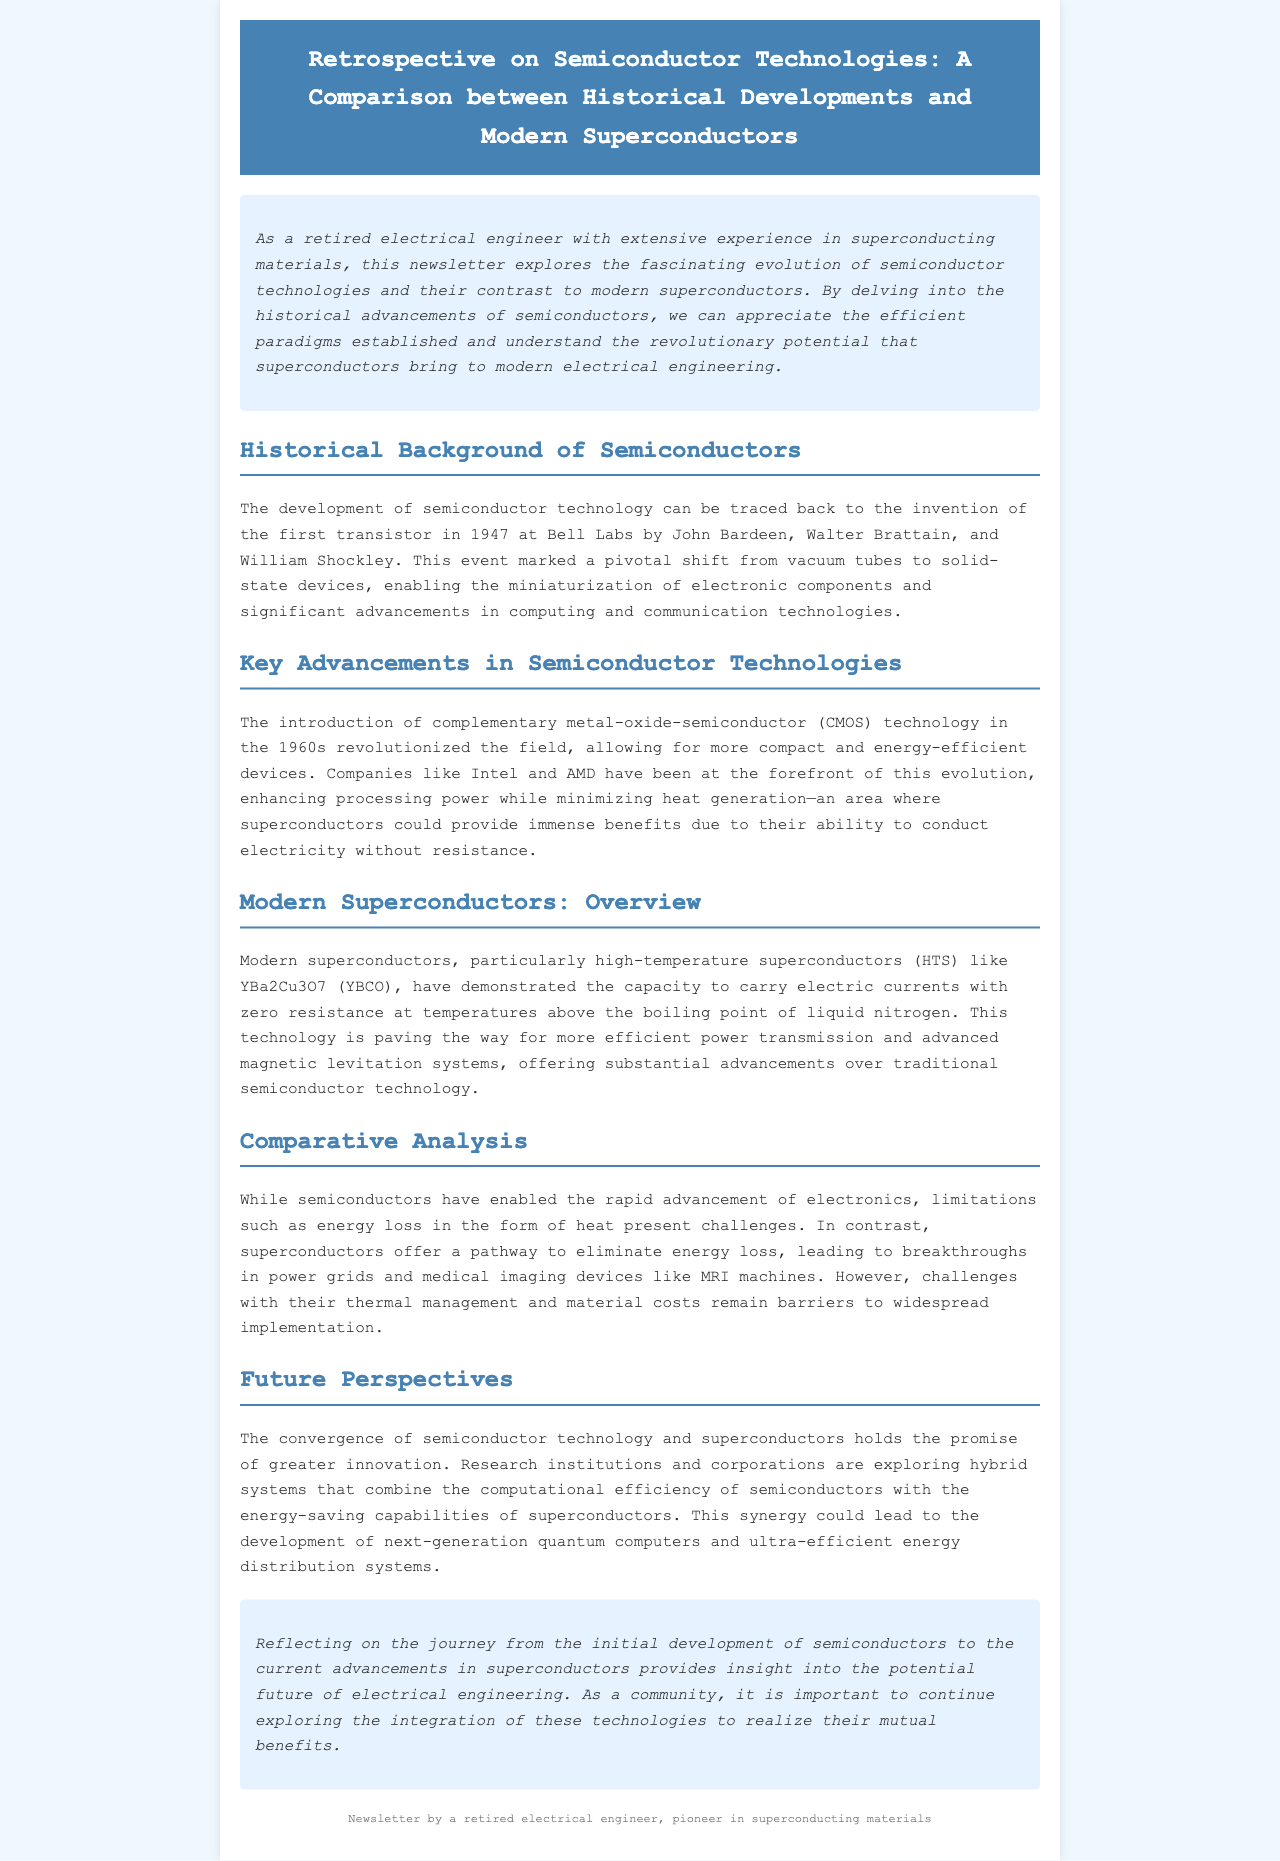What year was the first transistor invented? The document states that the first transistor was invented in 1947 at Bell Labs.
Answer: 1947 Which technology revolutionized the field of semiconductors in the 1960s? The introduction of complementary metal-oxide-semiconductor (CMOS) technology in the 1960s is mentioned as a revolutionary advancement.
Answer: CMOS technology What is an example of a modern superconductor provided in the newsletter? The document mentions YBa2Cu3O7 (YBCO) as an example of a high-temperature superconductor.
Answer: YBa2Cu3O7 (YBCO) What is a key benefit of superconductors over traditional semiconductors? The newsletter discusses the ability of superconductors to eliminate energy loss, a key benefit over traditional semiconductors which lose energy as heat.
Answer: Eliminate energy loss What potential applications for superconductors are mentioned in the document? The document states that superconductors offer advancements in power grids and medical imaging devices like MRI machines.
Answer: Power grids and MRI machines 